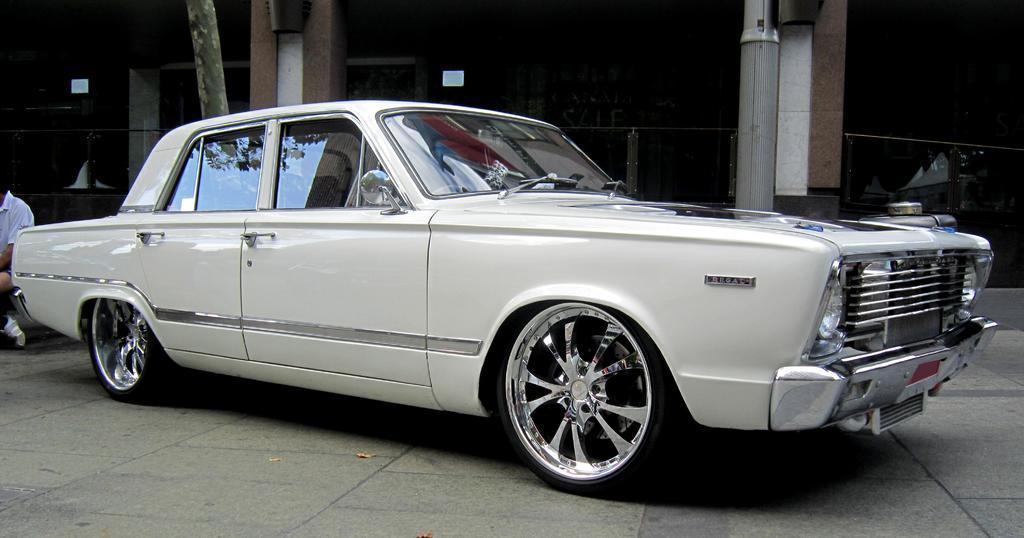Can you describe this image briefly? In the foreground I can see a car on the road. I can see a man on the left side and he is wearing a white color T-shirt. In the background, I can see the pillars of the building. 